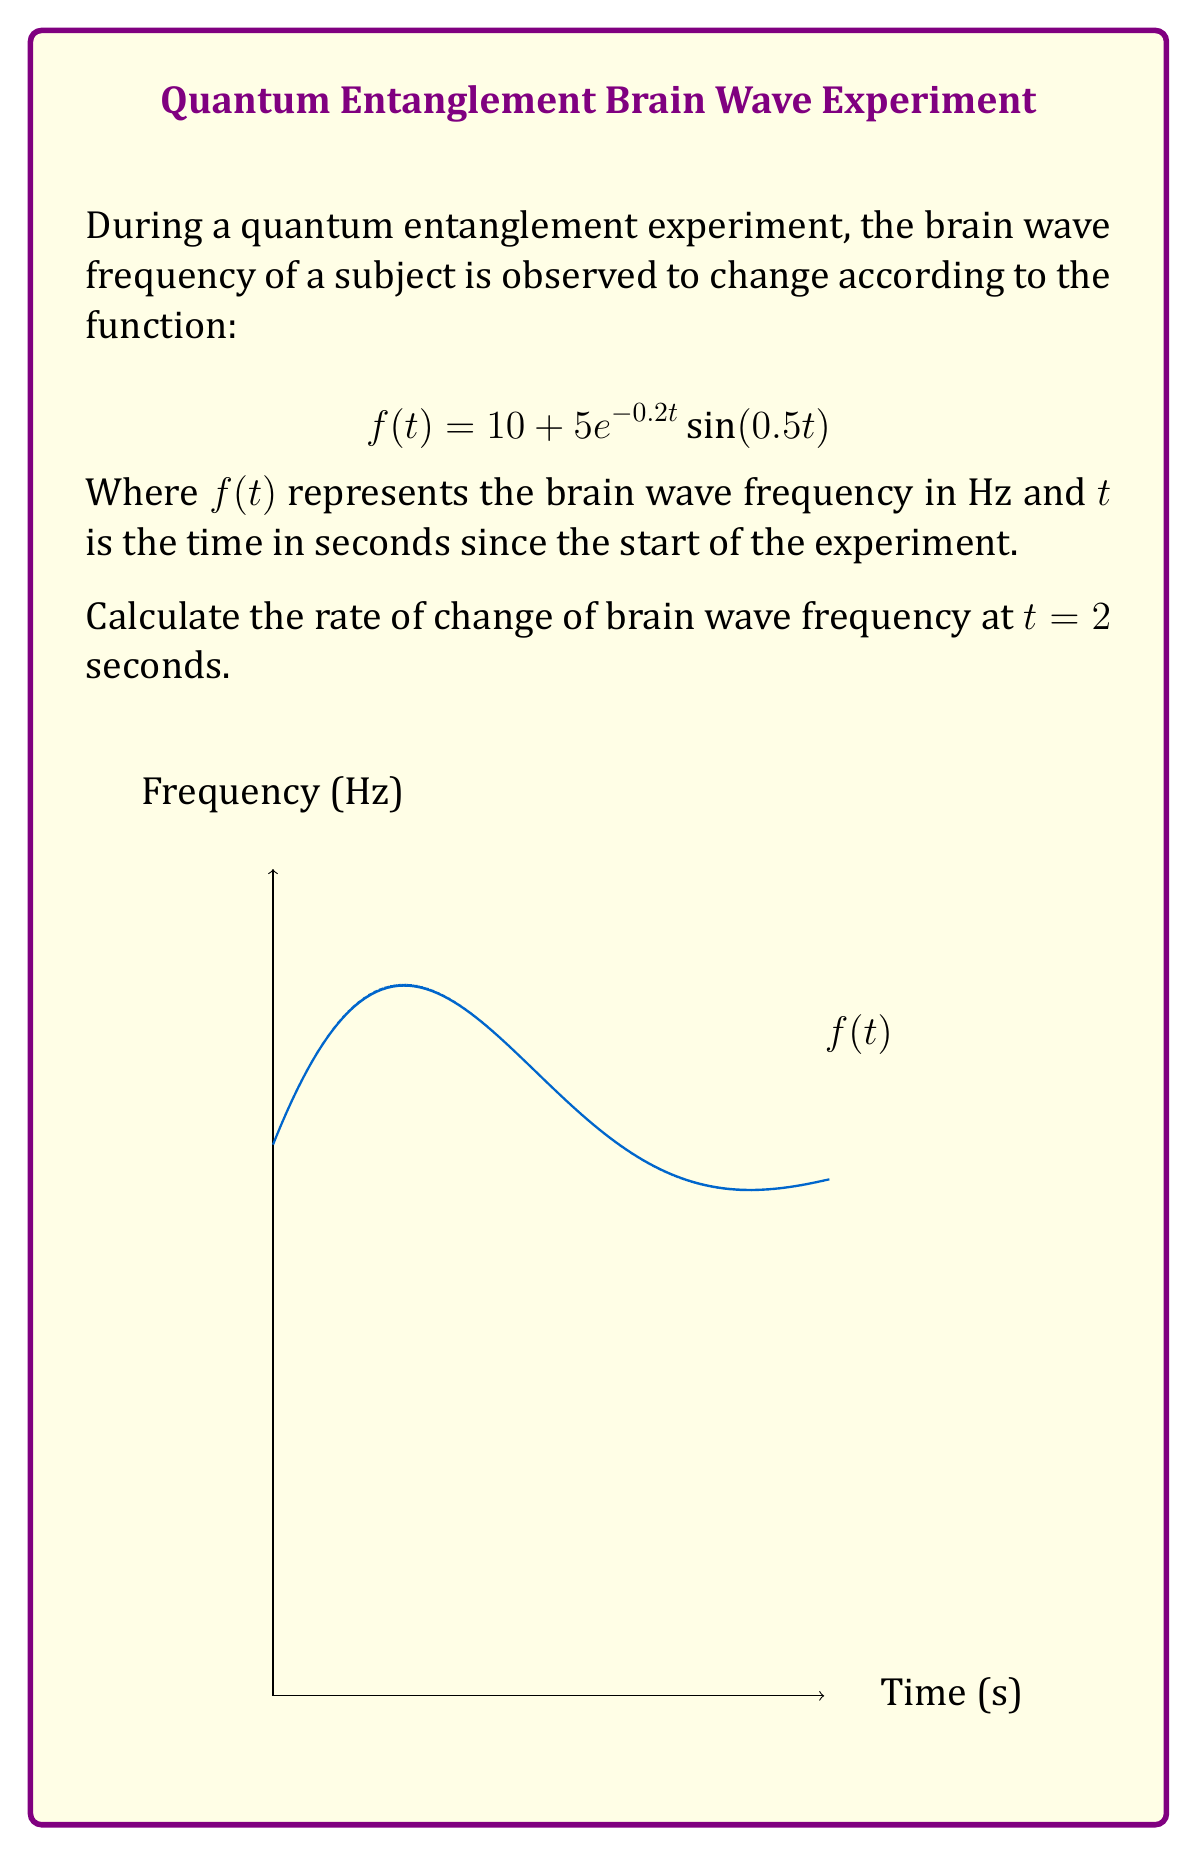Show me your answer to this math problem. To find the rate of change of brain wave frequency at $t = 2$ seconds, we need to calculate the derivative of $f(t)$ and then evaluate it at $t = 2$.

Step 1: Find $f'(t)$ using the product rule and chain rule.
$$f'(t) = \frac{d}{dt}[10 + 5e^{-0.2t}\sin(0.5t)]$$
$$f'(t) = 0 + 5[-0.2e^{-0.2t}\sin(0.5t) + e^{-0.2t}\cos(0.5t) \cdot 0.5]$$
$$f'(t) = 5e^{-0.2t}[-0.2\sin(0.5t) + 0.5\cos(0.5t)]$$
$$f'(t) = 5e^{-0.2t}[0.5\cos(0.5t) - 0.2\sin(0.5t)]$$

Step 2: Evaluate $f'(t)$ at $t = 2$.
$$f'(2) = 5e^{-0.2(2)}[0.5\cos(0.5(2)) - 0.2\sin(0.5(2))]$$
$$f'(2) = 5e^{-0.4}[0.5\cos(1) - 0.2\sin(1)]$$

Step 3: Calculate the numerical value.
$$f'(2) \approx 5 \cdot 0.6703 \cdot [0.5 \cdot 0.5403 - 0.2 \cdot 0.8415]$$
$$f'(2) \approx 3.3515 \cdot [0.2702 - 0.1683]$$
$$f'(2) \approx 3.3515 \cdot 0.1019$$
$$f'(2) \approx 0.3415$$

The rate of change of brain wave frequency at $t = 2$ seconds is approximately 0.3415 Hz/s.
Answer: 0.3415 Hz/s 